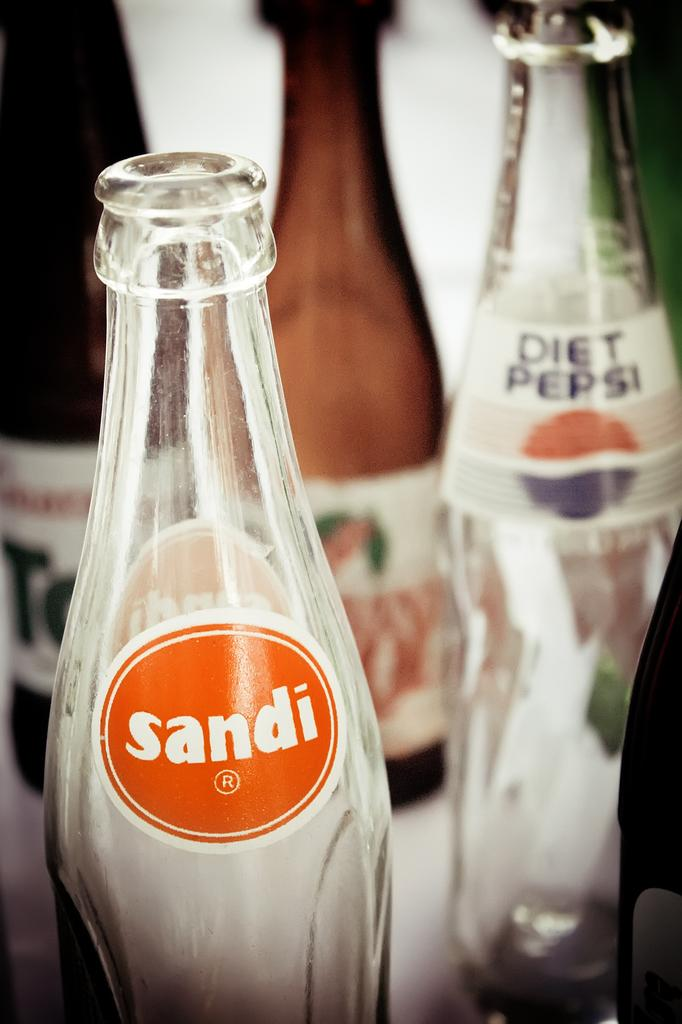<image>
Provide a brief description of the given image. A Sandi soda bottle sits on a table next to other bottles. 